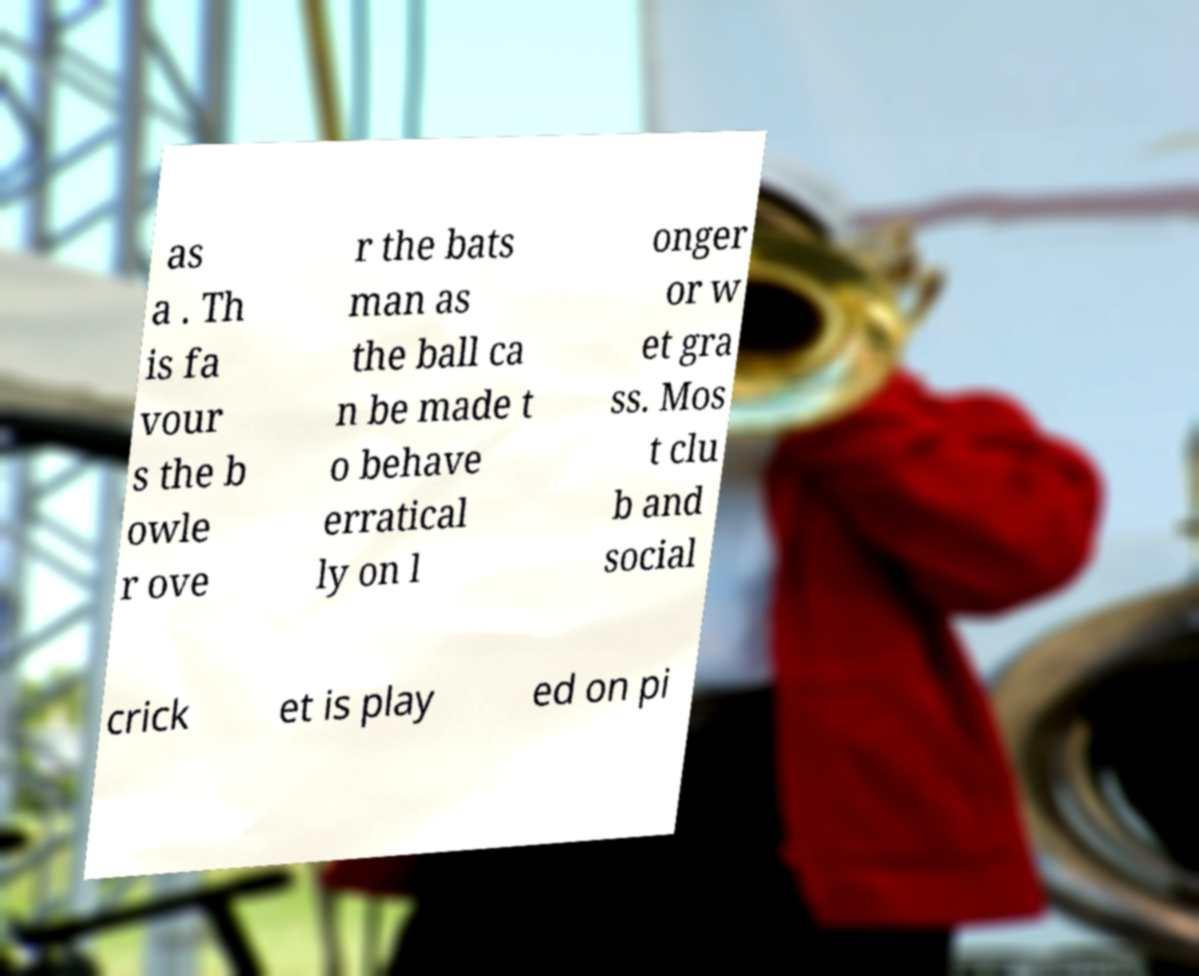Could you assist in decoding the text presented in this image and type it out clearly? as a . Th is fa vour s the b owle r ove r the bats man as the ball ca n be made t o behave erratical ly on l onger or w et gra ss. Mos t clu b and social crick et is play ed on pi 